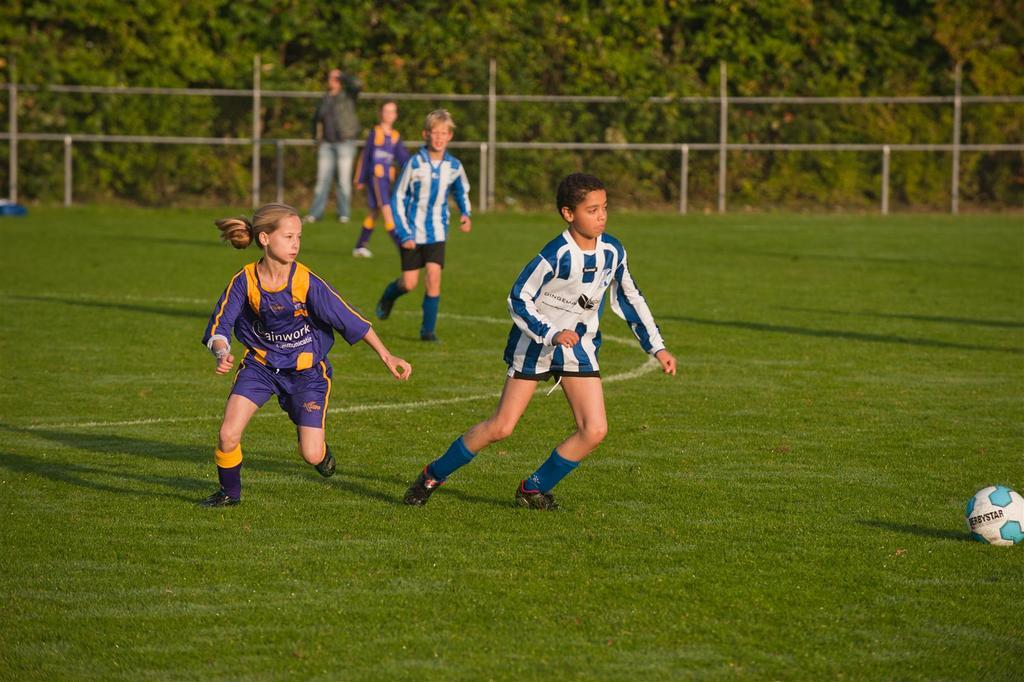What are the persons in the image doing? The persons in the middle of the image are playing football. What object is being used in the game? There is a football visible in the image. What can be seen in the background of the image? There are iron rods and trees in the background of the image. What type of stick can be seen being used by the players in the image? There is no stick visible in the image; the players are using a football to play the game. Is there a trail visible in the image? There is no trail present in the image; it features a football game being played in a field or open area. 